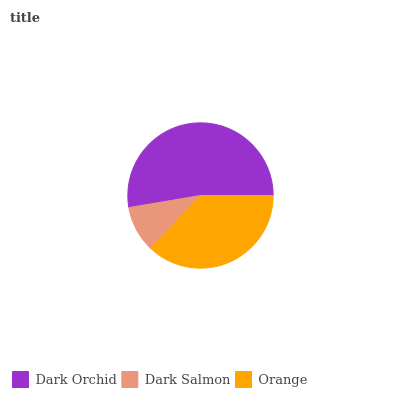Is Dark Salmon the minimum?
Answer yes or no. Yes. Is Dark Orchid the maximum?
Answer yes or no. Yes. Is Orange the minimum?
Answer yes or no. No. Is Orange the maximum?
Answer yes or no. No. Is Orange greater than Dark Salmon?
Answer yes or no. Yes. Is Dark Salmon less than Orange?
Answer yes or no. Yes. Is Dark Salmon greater than Orange?
Answer yes or no. No. Is Orange less than Dark Salmon?
Answer yes or no. No. Is Orange the high median?
Answer yes or no. Yes. Is Orange the low median?
Answer yes or no. Yes. Is Dark Salmon the high median?
Answer yes or no. No. Is Dark Salmon the low median?
Answer yes or no. No. 